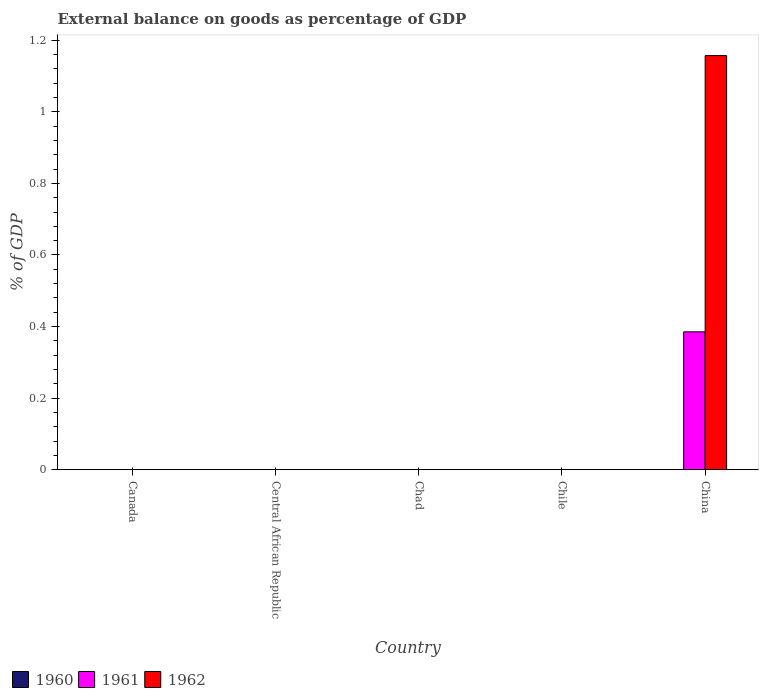How many different coloured bars are there?
Offer a terse response. 2. Are the number of bars on each tick of the X-axis equal?
Make the answer very short. No. How many bars are there on the 4th tick from the left?
Make the answer very short. 0. In how many cases, is the number of bars for a given country not equal to the number of legend labels?
Give a very brief answer. 5. Across all countries, what is the maximum external balance on goods as percentage of GDP in 1961?
Your answer should be very brief. 0.39. What is the total external balance on goods as percentage of GDP in 1962 in the graph?
Offer a very short reply. 1.16. What is the difference between the external balance on goods as percentage of GDP in 1960 in Canada and the external balance on goods as percentage of GDP in 1962 in China?
Keep it short and to the point. -1.16. What is the average external balance on goods as percentage of GDP in 1961 per country?
Offer a very short reply. 0.08. What is the difference between the external balance on goods as percentage of GDP of/in 1962 and external balance on goods as percentage of GDP of/in 1961 in China?
Provide a short and direct response. 0.77. What is the difference between the highest and the lowest external balance on goods as percentage of GDP in 1962?
Your response must be concise. 1.16. Are all the bars in the graph horizontal?
Your response must be concise. No. Are the values on the major ticks of Y-axis written in scientific E-notation?
Make the answer very short. No. Does the graph contain grids?
Your response must be concise. No. Where does the legend appear in the graph?
Ensure brevity in your answer.  Bottom left. How are the legend labels stacked?
Give a very brief answer. Horizontal. What is the title of the graph?
Keep it short and to the point. External balance on goods as percentage of GDP. Does "1970" appear as one of the legend labels in the graph?
Keep it short and to the point. No. What is the label or title of the Y-axis?
Make the answer very short. % of GDP. What is the % of GDP of 1960 in Canada?
Give a very brief answer. 0. What is the % of GDP of 1961 in Canada?
Your answer should be compact. 0. What is the % of GDP in 1962 in Canada?
Your answer should be very brief. 0. What is the % of GDP in 1960 in Central African Republic?
Ensure brevity in your answer.  0. What is the % of GDP of 1962 in Central African Republic?
Provide a succinct answer. 0. What is the % of GDP of 1961 in Chad?
Ensure brevity in your answer.  0. What is the % of GDP of 1960 in Chile?
Your answer should be very brief. 0. What is the % of GDP in 1960 in China?
Offer a very short reply. 0. What is the % of GDP of 1961 in China?
Keep it short and to the point. 0.39. What is the % of GDP of 1962 in China?
Your response must be concise. 1.16. Across all countries, what is the maximum % of GDP of 1961?
Keep it short and to the point. 0.39. Across all countries, what is the maximum % of GDP in 1962?
Make the answer very short. 1.16. Across all countries, what is the minimum % of GDP of 1961?
Offer a terse response. 0. Across all countries, what is the minimum % of GDP of 1962?
Keep it short and to the point. 0. What is the total % of GDP in 1961 in the graph?
Your answer should be compact. 0.39. What is the total % of GDP of 1962 in the graph?
Your answer should be compact. 1.16. What is the average % of GDP of 1960 per country?
Offer a terse response. 0. What is the average % of GDP in 1961 per country?
Provide a short and direct response. 0.08. What is the average % of GDP in 1962 per country?
Offer a very short reply. 0.23. What is the difference between the % of GDP in 1961 and % of GDP in 1962 in China?
Your answer should be very brief. -0.77. What is the difference between the highest and the lowest % of GDP in 1961?
Your answer should be very brief. 0.39. What is the difference between the highest and the lowest % of GDP of 1962?
Provide a short and direct response. 1.16. 